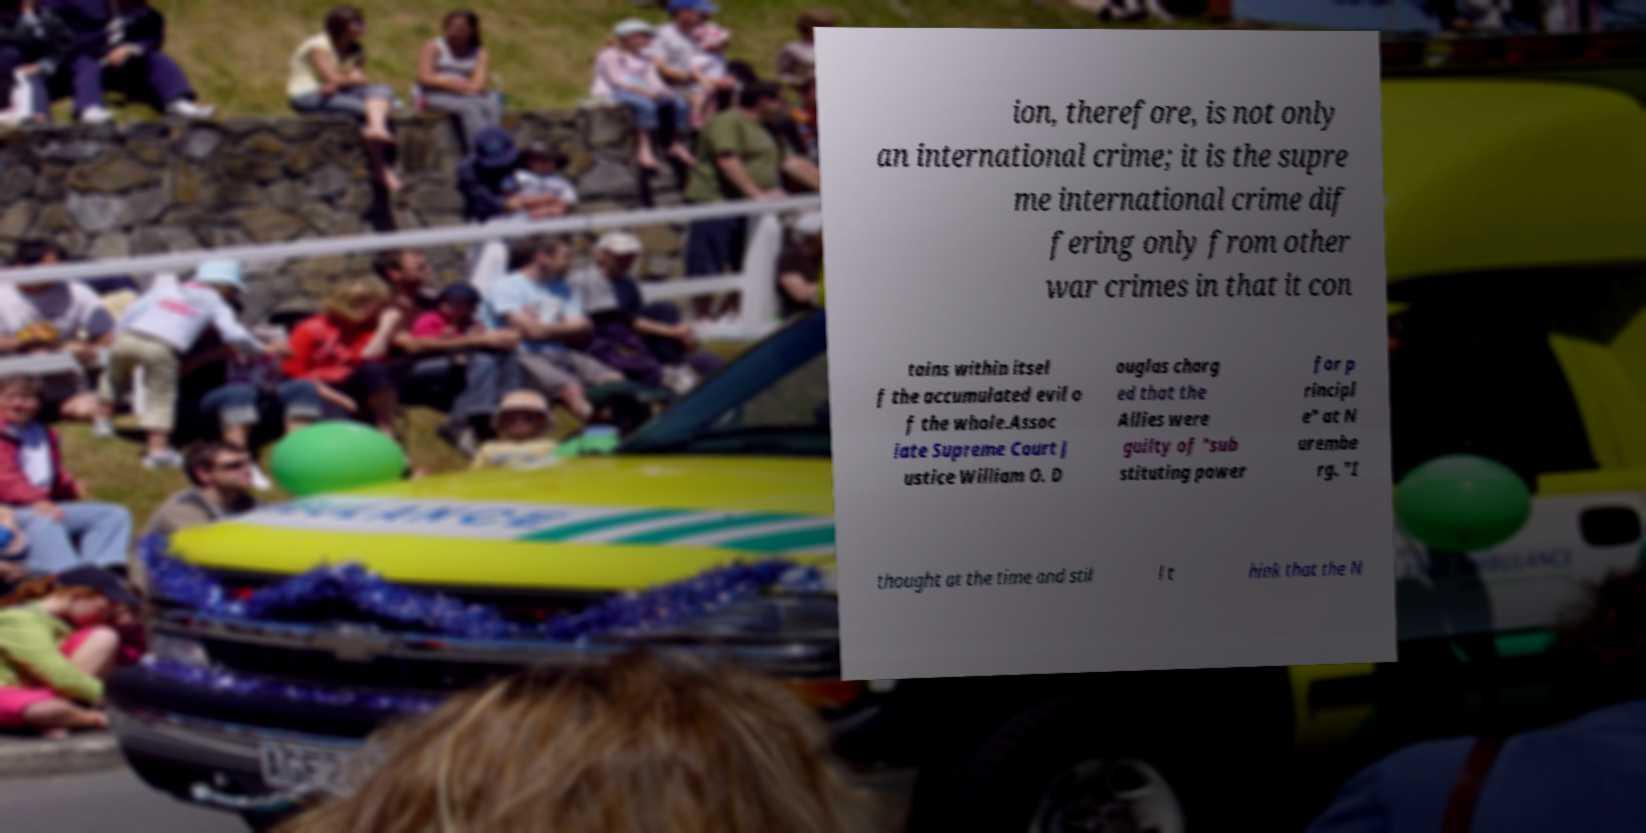Please identify and transcribe the text found in this image. ion, therefore, is not only an international crime; it is the supre me international crime dif fering only from other war crimes in that it con tains within itsel f the accumulated evil o f the whole.Assoc iate Supreme Court J ustice William O. D ouglas charg ed that the Allies were guilty of "sub stituting power for p rincipl e" at N urembe rg. "I thought at the time and stil l t hink that the N 